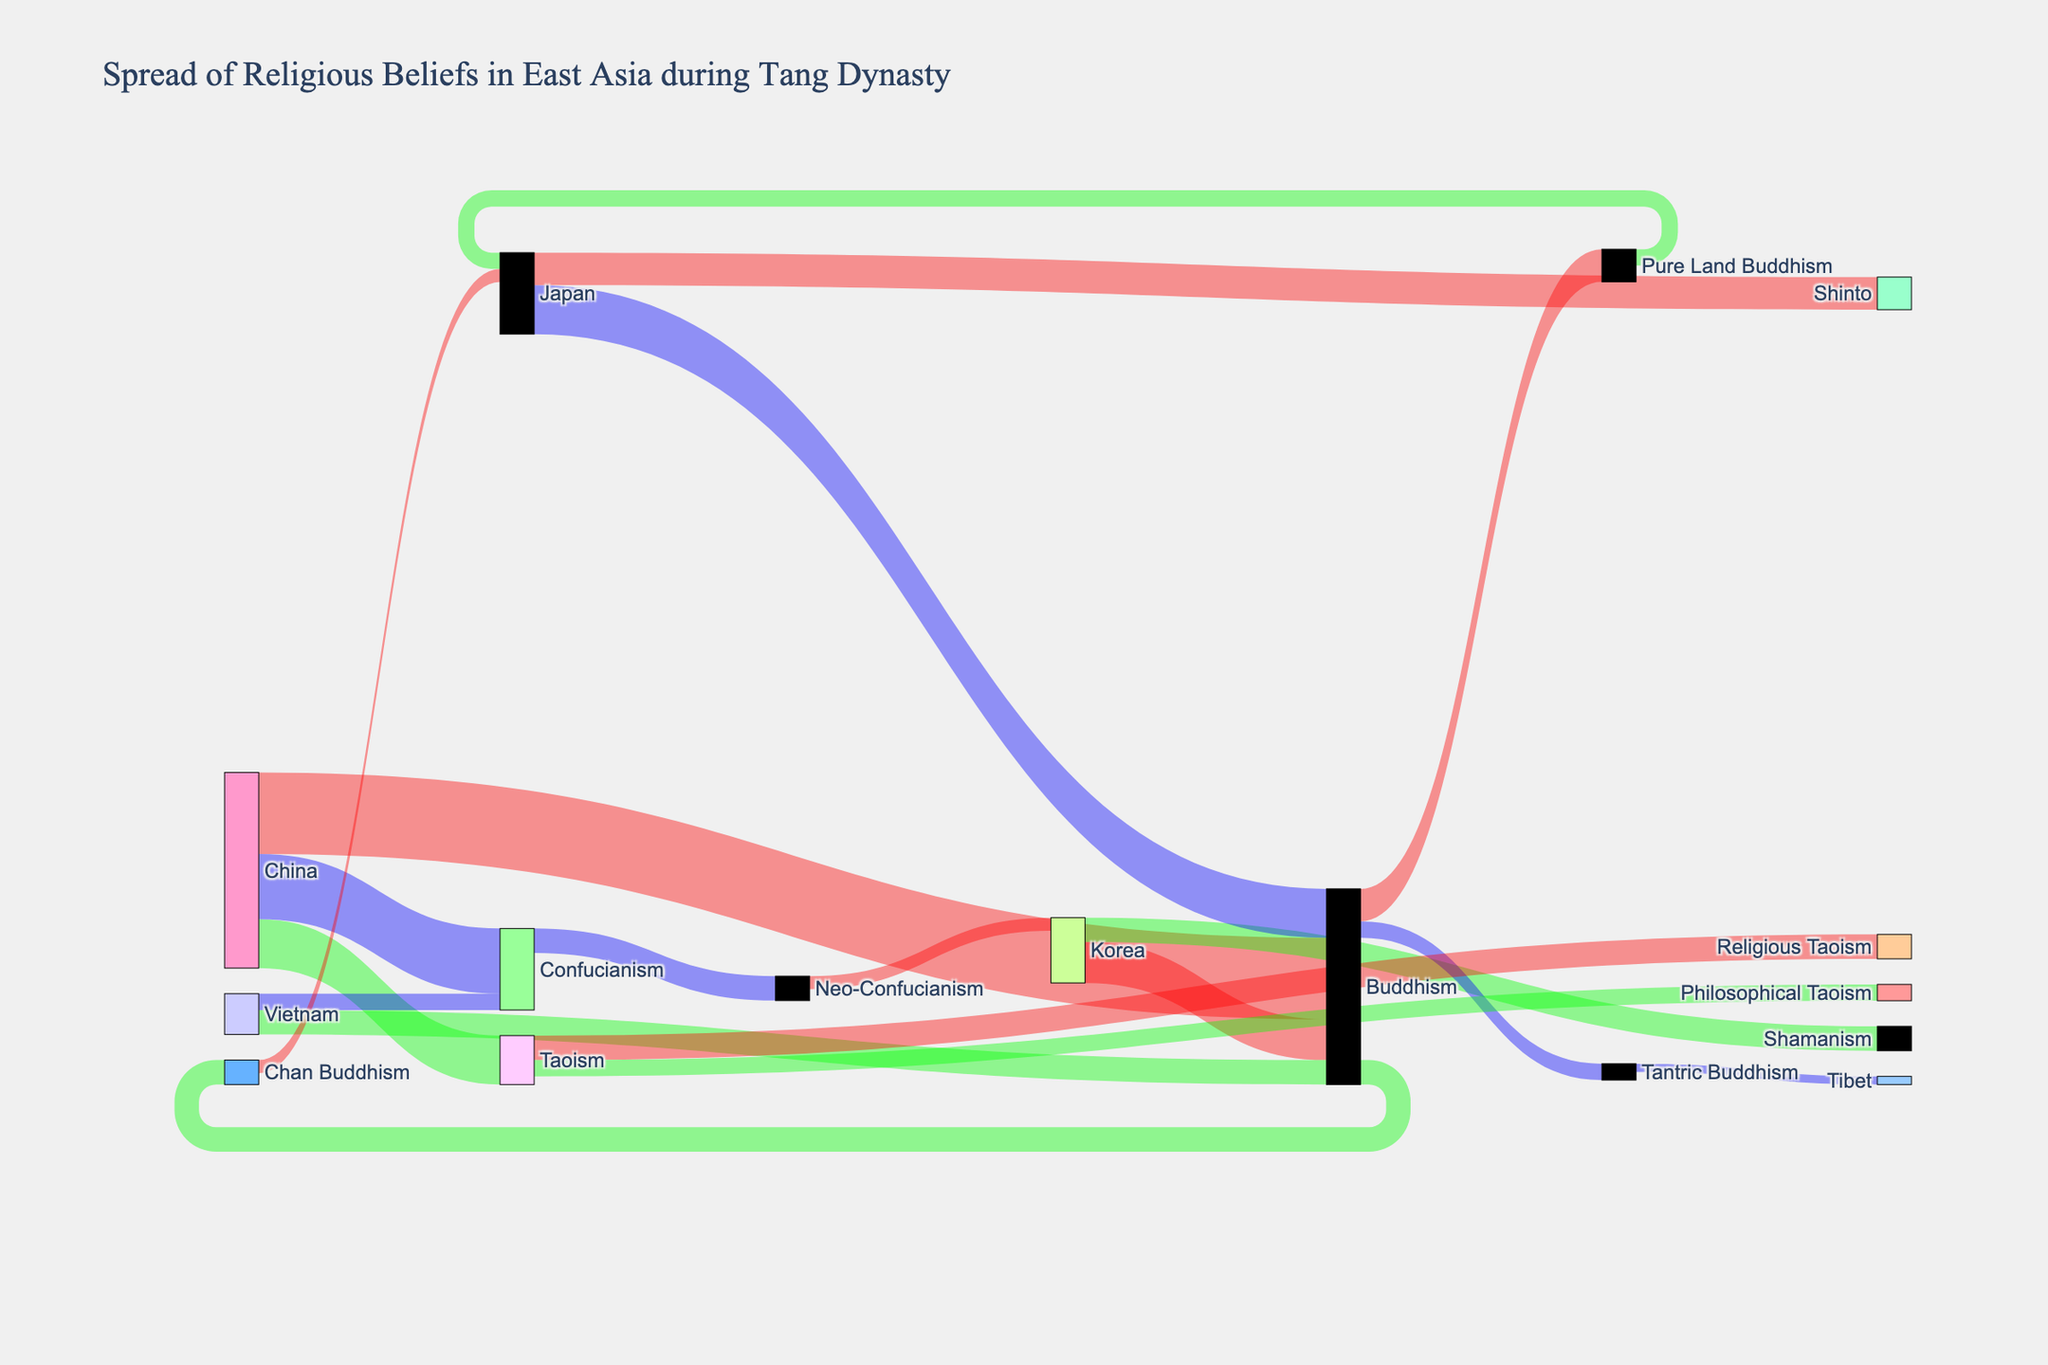In which country did Buddhism spread the least according to the figure? The countries listed that received Buddhism are Korea (250), Japan (300), and Vietnam (150). Among these, Vietnam received the least spread of Buddhism with a value of 150.
Answer: Vietnam Which form of Buddhism was most prominent in Japan? The Sankey Diagram indicates two forms of Buddhism spreading to Japan: Chan Buddhism (80) and Pure Land Buddhism (100). Pure Land Buddhism, with a value of 100, is more prominent than Chan Buddhism (80).
Answer: Pure Land Buddhism Compare the spread of religious beliefs from China to Vietnam. Which belief was more prominent? The Sankey Diagram shows that Buddhism (150) and Confucianism (100) spread to Vietnam from China. Comparing the values, Buddhism with 150 is more prominent than Confucianism with 100.
Answer: Buddhism How does the spread of Neo-Confucianism compare between Korea and Japan? The Sankey Diagram shows Neo-Confucianism spreading to Korea with a value of 80. There's no indication of Neo-Confucianism spreading to Japan, so it only spread to Korea according to the figure.
Answer: Only Korea What is the total spread of Buddhism across East Asia during the Tang Dynasty? The total spread of Buddhism can be calculated by adding the values of Buddhism's spread to various destinations from the Sankey Diagram: Korea (250), Japan (300), and Vietnam (150). Thus, the total spread is 250 + 300 + 150 = 700.
Answer: 700 What religious belief from China has the smallest spread indicated in the figure? From the Sankey Diagram, China spreads Buddhism (500), Taoism (300), and Confucianism (400). Among these, Taoism has the smallest initial spread with a value of 300.
Answer: Taoism 